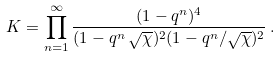Convert formula to latex. <formula><loc_0><loc_0><loc_500><loc_500>K = \prod _ { n = 1 } ^ { \infty } \frac { ( 1 - q ^ { n } ) ^ { 4 } } { ( 1 - q ^ { n } \, \sqrt { \chi } ) ^ { 2 } ( 1 - q ^ { n } / \sqrt { \chi } ) ^ { 2 } } \, .</formula> 